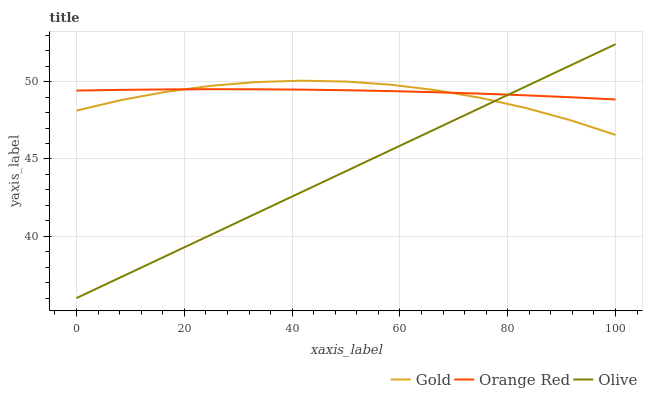Does Olive have the minimum area under the curve?
Answer yes or no. Yes. Does Orange Red have the maximum area under the curve?
Answer yes or no. Yes. Does Gold have the minimum area under the curve?
Answer yes or no. No. Does Gold have the maximum area under the curve?
Answer yes or no. No. Is Olive the smoothest?
Answer yes or no. Yes. Is Gold the roughest?
Answer yes or no. Yes. Is Orange Red the smoothest?
Answer yes or no. No. Is Orange Red the roughest?
Answer yes or no. No. Does Olive have the lowest value?
Answer yes or no. Yes. Does Gold have the lowest value?
Answer yes or no. No. Does Olive have the highest value?
Answer yes or no. Yes. Does Gold have the highest value?
Answer yes or no. No. Does Olive intersect Gold?
Answer yes or no. Yes. Is Olive less than Gold?
Answer yes or no. No. Is Olive greater than Gold?
Answer yes or no. No. 